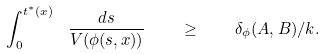<formula> <loc_0><loc_0><loc_500><loc_500>\int _ { 0 } ^ { t ^ { * } ( x ) } \ \frac { d s } { V ( \phi ( s , x ) ) } \quad \geq \quad \delta _ { \phi } ( A , B ) / k .</formula> 